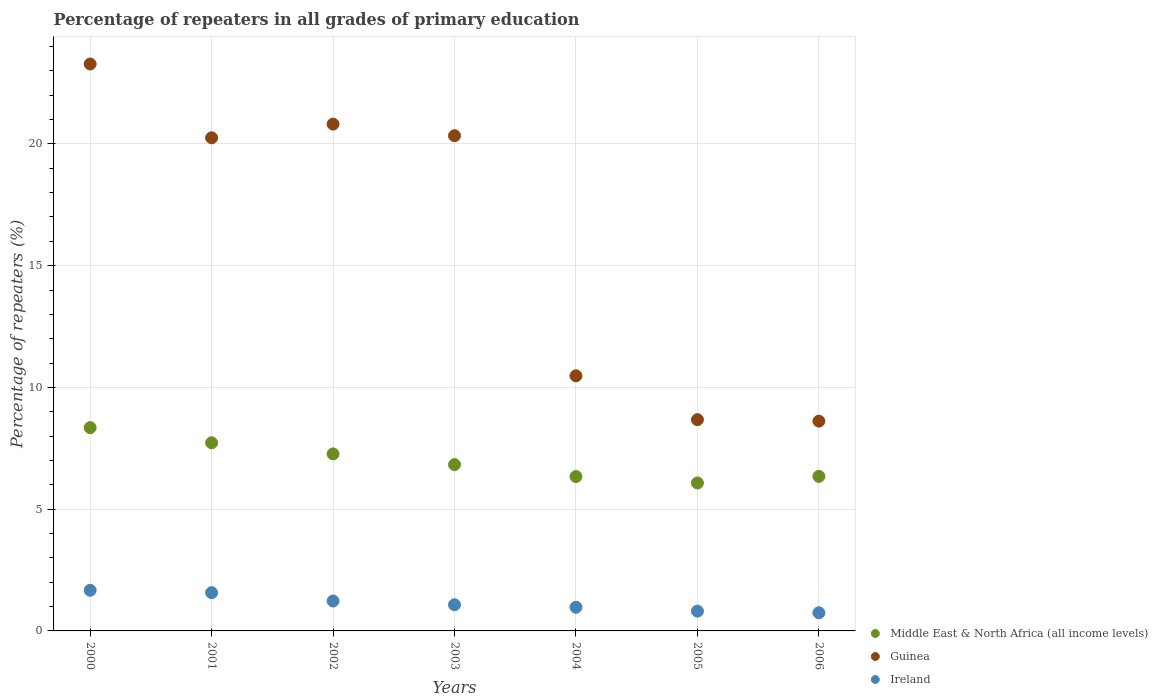How many different coloured dotlines are there?
Offer a very short reply. 3. Is the number of dotlines equal to the number of legend labels?
Make the answer very short. Yes. What is the percentage of repeaters in Middle East & North Africa (all income levels) in 2002?
Your answer should be compact. 7.27. Across all years, what is the maximum percentage of repeaters in Guinea?
Your answer should be compact. 23.28. Across all years, what is the minimum percentage of repeaters in Guinea?
Your answer should be very brief. 8.62. What is the total percentage of repeaters in Ireland in the graph?
Provide a short and direct response. 8.07. What is the difference between the percentage of repeaters in Ireland in 2000 and that in 2004?
Keep it short and to the point. 0.7. What is the difference between the percentage of repeaters in Ireland in 2003 and the percentage of repeaters in Middle East & North Africa (all income levels) in 2000?
Your answer should be very brief. -7.27. What is the average percentage of repeaters in Ireland per year?
Give a very brief answer. 1.15. In the year 2000, what is the difference between the percentage of repeaters in Middle East & North Africa (all income levels) and percentage of repeaters in Ireland?
Offer a very short reply. 6.68. In how many years, is the percentage of repeaters in Middle East & North Africa (all income levels) greater than 9 %?
Your response must be concise. 0. What is the ratio of the percentage of repeaters in Ireland in 2002 to that in 2003?
Give a very brief answer. 1.14. Is the difference between the percentage of repeaters in Middle East & North Africa (all income levels) in 2001 and 2004 greater than the difference between the percentage of repeaters in Ireland in 2001 and 2004?
Your answer should be compact. Yes. What is the difference between the highest and the second highest percentage of repeaters in Guinea?
Offer a very short reply. 2.47. What is the difference between the highest and the lowest percentage of repeaters in Guinea?
Keep it short and to the point. 14.67. Is it the case that in every year, the sum of the percentage of repeaters in Ireland and percentage of repeaters in Middle East & North Africa (all income levels)  is greater than the percentage of repeaters in Guinea?
Give a very brief answer. No. Is the percentage of repeaters in Ireland strictly less than the percentage of repeaters in Middle East & North Africa (all income levels) over the years?
Provide a short and direct response. Yes. What is the difference between two consecutive major ticks on the Y-axis?
Provide a succinct answer. 5. Does the graph contain grids?
Give a very brief answer. Yes. Where does the legend appear in the graph?
Your response must be concise. Bottom right. What is the title of the graph?
Offer a terse response. Percentage of repeaters in all grades of primary education. What is the label or title of the X-axis?
Make the answer very short. Years. What is the label or title of the Y-axis?
Provide a succinct answer. Percentage of repeaters (%). What is the Percentage of repeaters (%) in Middle East & North Africa (all income levels) in 2000?
Make the answer very short. 8.35. What is the Percentage of repeaters (%) of Guinea in 2000?
Provide a short and direct response. 23.28. What is the Percentage of repeaters (%) in Ireland in 2000?
Make the answer very short. 1.67. What is the Percentage of repeaters (%) of Middle East & North Africa (all income levels) in 2001?
Offer a very short reply. 7.73. What is the Percentage of repeaters (%) of Guinea in 2001?
Your answer should be compact. 20.25. What is the Percentage of repeaters (%) in Ireland in 2001?
Your answer should be very brief. 1.57. What is the Percentage of repeaters (%) in Middle East & North Africa (all income levels) in 2002?
Your response must be concise. 7.27. What is the Percentage of repeaters (%) of Guinea in 2002?
Make the answer very short. 20.81. What is the Percentage of repeaters (%) in Ireland in 2002?
Make the answer very short. 1.23. What is the Percentage of repeaters (%) in Middle East & North Africa (all income levels) in 2003?
Ensure brevity in your answer.  6.83. What is the Percentage of repeaters (%) in Guinea in 2003?
Offer a very short reply. 20.34. What is the Percentage of repeaters (%) in Ireland in 2003?
Provide a short and direct response. 1.07. What is the Percentage of repeaters (%) in Middle East & North Africa (all income levels) in 2004?
Offer a terse response. 6.34. What is the Percentage of repeaters (%) in Guinea in 2004?
Your answer should be very brief. 10.48. What is the Percentage of repeaters (%) in Ireland in 2004?
Make the answer very short. 0.97. What is the Percentage of repeaters (%) in Middle East & North Africa (all income levels) in 2005?
Your answer should be very brief. 6.08. What is the Percentage of repeaters (%) of Guinea in 2005?
Provide a short and direct response. 8.68. What is the Percentage of repeaters (%) in Ireland in 2005?
Your response must be concise. 0.81. What is the Percentage of repeaters (%) in Middle East & North Africa (all income levels) in 2006?
Provide a short and direct response. 6.35. What is the Percentage of repeaters (%) of Guinea in 2006?
Give a very brief answer. 8.62. What is the Percentage of repeaters (%) of Ireland in 2006?
Your answer should be very brief. 0.75. Across all years, what is the maximum Percentage of repeaters (%) of Middle East & North Africa (all income levels)?
Your answer should be compact. 8.35. Across all years, what is the maximum Percentage of repeaters (%) of Guinea?
Offer a terse response. 23.28. Across all years, what is the maximum Percentage of repeaters (%) in Ireland?
Provide a succinct answer. 1.67. Across all years, what is the minimum Percentage of repeaters (%) in Middle East & North Africa (all income levels)?
Your response must be concise. 6.08. Across all years, what is the minimum Percentage of repeaters (%) in Guinea?
Provide a succinct answer. 8.62. Across all years, what is the minimum Percentage of repeaters (%) in Ireland?
Make the answer very short. 0.75. What is the total Percentage of repeaters (%) of Middle East & North Africa (all income levels) in the graph?
Provide a short and direct response. 48.94. What is the total Percentage of repeaters (%) of Guinea in the graph?
Offer a very short reply. 112.45. What is the total Percentage of repeaters (%) of Ireland in the graph?
Make the answer very short. 8.07. What is the difference between the Percentage of repeaters (%) in Middle East & North Africa (all income levels) in 2000 and that in 2001?
Your response must be concise. 0.62. What is the difference between the Percentage of repeaters (%) in Guinea in 2000 and that in 2001?
Provide a short and direct response. 3.03. What is the difference between the Percentage of repeaters (%) in Ireland in 2000 and that in 2001?
Ensure brevity in your answer.  0.1. What is the difference between the Percentage of repeaters (%) of Middle East & North Africa (all income levels) in 2000 and that in 2002?
Ensure brevity in your answer.  1.08. What is the difference between the Percentage of repeaters (%) in Guinea in 2000 and that in 2002?
Offer a very short reply. 2.47. What is the difference between the Percentage of repeaters (%) in Ireland in 2000 and that in 2002?
Your answer should be very brief. 0.44. What is the difference between the Percentage of repeaters (%) in Middle East & North Africa (all income levels) in 2000 and that in 2003?
Offer a terse response. 1.52. What is the difference between the Percentage of repeaters (%) of Guinea in 2000 and that in 2003?
Offer a terse response. 2.94. What is the difference between the Percentage of repeaters (%) in Ireland in 2000 and that in 2003?
Your answer should be very brief. 0.59. What is the difference between the Percentage of repeaters (%) in Middle East & North Africa (all income levels) in 2000 and that in 2004?
Offer a very short reply. 2.01. What is the difference between the Percentage of repeaters (%) of Guinea in 2000 and that in 2004?
Provide a short and direct response. 12.8. What is the difference between the Percentage of repeaters (%) of Ireland in 2000 and that in 2004?
Ensure brevity in your answer.  0.7. What is the difference between the Percentage of repeaters (%) of Middle East & North Africa (all income levels) in 2000 and that in 2005?
Provide a short and direct response. 2.27. What is the difference between the Percentage of repeaters (%) in Guinea in 2000 and that in 2005?
Your answer should be very brief. 14.61. What is the difference between the Percentage of repeaters (%) in Ireland in 2000 and that in 2005?
Offer a terse response. 0.86. What is the difference between the Percentage of repeaters (%) of Middle East & North Africa (all income levels) in 2000 and that in 2006?
Keep it short and to the point. 2. What is the difference between the Percentage of repeaters (%) in Guinea in 2000 and that in 2006?
Offer a very short reply. 14.67. What is the difference between the Percentage of repeaters (%) of Ireland in 2000 and that in 2006?
Keep it short and to the point. 0.92. What is the difference between the Percentage of repeaters (%) in Middle East & North Africa (all income levels) in 2001 and that in 2002?
Ensure brevity in your answer.  0.46. What is the difference between the Percentage of repeaters (%) of Guinea in 2001 and that in 2002?
Your answer should be very brief. -0.56. What is the difference between the Percentage of repeaters (%) in Ireland in 2001 and that in 2002?
Give a very brief answer. 0.34. What is the difference between the Percentage of repeaters (%) of Middle East & North Africa (all income levels) in 2001 and that in 2003?
Your answer should be compact. 0.9. What is the difference between the Percentage of repeaters (%) of Guinea in 2001 and that in 2003?
Give a very brief answer. -0.09. What is the difference between the Percentage of repeaters (%) in Ireland in 2001 and that in 2003?
Offer a terse response. 0.5. What is the difference between the Percentage of repeaters (%) in Middle East & North Africa (all income levels) in 2001 and that in 2004?
Offer a terse response. 1.39. What is the difference between the Percentage of repeaters (%) of Guinea in 2001 and that in 2004?
Your response must be concise. 9.77. What is the difference between the Percentage of repeaters (%) of Ireland in 2001 and that in 2004?
Offer a terse response. 0.6. What is the difference between the Percentage of repeaters (%) of Middle East & North Africa (all income levels) in 2001 and that in 2005?
Your response must be concise. 1.65. What is the difference between the Percentage of repeaters (%) in Guinea in 2001 and that in 2005?
Your answer should be very brief. 11.58. What is the difference between the Percentage of repeaters (%) in Ireland in 2001 and that in 2005?
Offer a very short reply. 0.76. What is the difference between the Percentage of repeaters (%) of Middle East & North Africa (all income levels) in 2001 and that in 2006?
Your answer should be very brief. 1.38. What is the difference between the Percentage of repeaters (%) of Guinea in 2001 and that in 2006?
Ensure brevity in your answer.  11.64. What is the difference between the Percentage of repeaters (%) in Ireland in 2001 and that in 2006?
Offer a very short reply. 0.82. What is the difference between the Percentage of repeaters (%) of Middle East & North Africa (all income levels) in 2002 and that in 2003?
Give a very brief answer. 0.44. What is the difference between the Percentage of repeaters (%) in Guinea in 2002 and that in 2003?
Provide a short and direct response. 0.48. What is the difference between the Percentage of repeaters (%) in Ireland in 2002 and that in 2003?
Make the answer very short. 0.15. What is the difference between the Percentage of repeaters (%) in Middle East & North Africa (all income levels) in 2002 and that in 2004?
Your answer should be compact. 0.93. What is the difference between the Percentage of repeaters (%) of Guinea in 2002 and that in 2004?
Provide a succinct answer. 10.34. What is the difference between the Percentage of repeaters (%) of Ireland in 2002 and that in 2004?
Keep it short and to the point. 0.26. What is the difference between the Percentage of repeaters (%) in Middle East & North Africa (all income levels) in 2002 and that in 2005?
Keep it short and to the point. 1.19. What is the difference between the Percentage of repeaters (%) of Guinea in 2002 and that in 2005?
Provide a succinct answer. 12.14. What is the difference between the Percentage of repeaters (%) in Ireland in 2002 and that in 2005?
Your response must be concise. 0.42. What is the difference between the Percentage of repeaters (%) of Middle East & North Africa (all income levels) in 2002 and that in 2006?
Your response must be concise. 0.92. What is the difference between the Percentage of repeaters (%) of Guinea in 2002 and that in 2006?
Give a very brief answer. 12.2. What is the difference between the Percentage of repeaters (%) of Ireland in 2002 and that in 2006?
Make the answer very short. 0.48. What is the difference between the Percentage of repeaters (%) in Middle East & North Africa (all income levels) in 2003 and that in 2004?
Ensure brevity in your answer.  0.49. What is the difference between the Percentage of repeaters (%) in Guinea in 2003 and that in 2004?
Provide a succinct answer. 9.86. What is the difference between the Percentage of repeaters (%) of Ireland in 2003 and that in 2004?
Keep it short and to the point. 0.1. What is the difference between the Percentage of repeaters (%) of Middle East & North Africa (all income levels) in 2003 and that in 2005?
Make the answer very short. 0.75. What is the difference between the Percentage of repeaters (%) in Guinea in 2003 and that in 2005?
Give a very brief answer. 11.66. What is the difference between the Percentage of repeaters (%) in Ireland in 2003 and that in 2005?
Offer a terse response. 0.26. What is the difference between the Percentage of repeaters (%) of Middle East & North Africa (all income levels) in 2003 and that in 2006?
Ensure brevity in your answer.  0.48. What is the difference between the Percentage of repeaters (%) of Guinea in 2003 and that in 2006?
Keep it short and to the point. 11.72. What is the difference between the Percentage of repeaters (%) in Ireland in 2003 and that in 2006?
Offer a terse response. 0.33. What is the difference between the Percentage of repeaters (%) in Middle East & North Africa (all income levels) in 2004 and that in 2005?
Ensure brevity in your answer.  0.26. What is the difference between the Percentage of repeaters (%) in Guinea in 2004 and that in 2005?
Keep it short and to the point. 1.8. What is the difference between the Percentage of repeaters (%) of Ireland in 2004 and that in 2005?
Offer a terse response. 0.16. What is the difference between the Percentage of repeaters (%) in Middle East & North Africa (all income levels) in 2004 and that in 2006?
Your answer should be very brief. -0. What is the difference between the Percentage of repeaters (%) of Guinea in 2004 and that in 2006?
Keep it short and to the point. 1.86. What is the difference between the Percentage of repeaters (%) in Ireland in 2004 and that in 2006?
Provide a succinct answer. 0.23. What is the difference between the Percentage of repeaters (%) in Middle East & North Africa (all income levels) in 2005 and that in 2006?
Make the answer very short. -0.27. What is the difference between the Percentage of repeaters (%) of Guinea in 2005 and that in 2006?
Provide a short and direct response. 0.06. What is the difference between the Percentage of repeaters (%) in Ireland in 2005 and that in 2006?
Offer a very short reply. 0.07. What is the difference between the Percentage of repeaters (%) of Middle East & North Africa (all income levels) in 2000 and the Percentage of repeaters (%) of Guinea in 2001?
Offer a very short reply. -11.9. What is the difference between the Percentage of repeaters (%) in Middle East & North Africa (all income levels) in 2000 and the Percentage of repeaters (%) in Ireland in 2001?
Your answer should be compact. 6.78. What is the difference between the Percentage of repeaters (%) of Guinea in 2000 and the Percentage of repeaters (%) of Ireland in 2001?
Ensure brevity in your answer.  21.71. What is the difference between the Percentage of repeaters (%) in Middle East & North Africa (all income levels) in 2000 and the Percentage of repeaters (%) in Guinea in 2002?
Your answer should be compact. -12.47. What is the difference between the Percentage of repeaters (%) of Middle East & North Africa (all income levels) in 2000 and the Percentage of repeaters (%) of Ireland in 2002?
Provide a short and direct response. 7.12. What is the difference between the Percentage of repeaters (%) in Guinea in 2000 and the Percentage of repeaters (%) in Ireland in 2002?
Give a very brief answer. 22.05. What is the difference between the Percentage of repeaters (%) in Middle East & North Africa (all income levels) in 2000 and the Percentage of repeaters (%) in Guinea in 2003?
Give a very brief answer. -11.99. What is the difference between the Percentage of repeaters (%) in Middle East & North Africa (all income levels) in 2000 and the Percentage of repeaters (%) in Ireland in 2003?
Keep it short and to the point. 7.27. What is the difference between the Percentage of repeaters (%) in Guinea in 2000 and the Percentage of repeaters (%) in Ireland in 2003?
Provide a short and direct response. 22.21. What is the difference between the Percentage of repeaters (%) of Middle East & North Africa (all income levels) in 2000 and the Percentage of repeaters (%) of Guinea in 2004?
Your answer should be very brief. -2.13. What is the difference between the Percentage of repeaters (%) of Middle East & North Africa (all income levels) in 2000 and the Percentage of repeaters (%) of Ireland in 2004?
Your response must be concise. 7.38. What is the difference between the Percentage of repeaters (%) of Guinea in 2000 and the Percentage of repeaters (%) of Ireland in 2004?
Ensure brevity in your answer.  22.31. What is the difference between the Percentage of repeaters (%) of Middle East & North Africa (all income levels) in 2000 and the Percentage of repeaters (%) of Guinea in 2005?
Make the answer very short. -0.33. What is the difference between the Percentage of repeaters (%) in Middle East & North Africa (all income levels) in 2000 and the Percentage of repeaters (%) in Ireland in 2005?
Offer a very short reply. 7.54. What is the difference between the Percentage of repeaters (%) in Guinea in 2000 and the Percentage of repeaters (%) in Ireland in 2005?
Offer a terse response. 22.47. What is the difference between the Percentage of repeaters (%) in Middle East & North Africa (all income levels) in 2000 and the Percentage of repeaters (%) in Guinea in 2006?
Keep it short and to the point. -0.27. What is the difference between the Percentage of repeaters (%) in Middle East & North Africa (all income levels) in 2000 and the Percentage of repeaters (%) in Ireland in 2006?
Your response must be concise. 7.6. What is the difference between the Percentage of repeaters (%) in Guinea in 2000 and the Percentage of repeaters (%) in Ireland in 2006?
Keep it short and to the point. 22.54. What is the difference between the Percentage of repeaters (%) in Middle East & North Africa (all income levels) in 2001 and the Percentage of repeaters (%) in Guinea in 2002?
Offer a terse response. -13.09. What is the difference between the Percentage of repeaters (%) of Middle East & North Africa (all income levels) in 2001 and the Percentage of repeaters (%) of Ireland in 2002?
Make the answer very short. 6.5. What is the difference between the Percentage of repeaters (%) of Guinea in 2001 and the Percentage of repeaters (%) of Ireland in 2002?
Ensure brevity in your answer.  19.02. What is the difference between the Percentage of repeaters (%) of Middle East & North Africa (all income levels) in 2001 and the Percentage of repeaters (%) of Guinea in 2003?
Offer a very short reply. -12.61. What is the difference between the Percentage of repeaters (%) in Middle East & North Africa (all income levels) in 2001 and the Percentage of repeaters (%) in Ireland in 2003?
Keep it short and to the point. 6.65. What is the difference between the Percentage of repeaters (%) in Guinea in 2001 and the Percentage of repeaters (%) in Ireland in 2003?
Offer a very short reply. 19.18. What is the difference between the Percentage of repeaters (%) in Middle East & North Africa (all income levels) in 2001 and the Percentage of repeaters (%) in Guinea in 2004?
Your response must be concise. -2.75. What is the difference between the Percentage of repeaters (%) of Middle East & North Africa (all income levels) in 2001 and the Percentage of repeaters (%) of Ireland in 2004?
Your answer should be very brief. 6.76. What is the difference between the Percentage of repeaters (%) of Guinea in 2001 and the Percentage of repeaters (%) of Ireland in 2004?
Keep it short and to the point. 19.28. What is the difference between the Percentage of repeaters (%) in Middle East & North Africa (all income levels) in 2001 and the Percentage of repeaters (%) in Guinea in 2005?
Ensure brevity in your answer.  -0.95. What is the difference between the Percentage of repeaters (%) in Middle East & North Africa (all income levels) in 2001 and the Percentage of repeaters (%) in Ireland in 2005?
Offer a terse response. 6.91. What is the difference between the Percentage of repeaters (%) in Guinea in 2001 and the Percentage of repeaters (%) in Ireland in 2005?
Keep it short and to the point. 19.44. What is the difference between the Percentage of repeaters (%) in Middle East & North Africa (all income levels) in 2001 and the Percentage of repeaters (%) in Guinea in 2006?
Your response must be concise. -0.89. What is the difference between the Percentage of repeaters (%) in Middle East & North Africa (all income levels) in 2001 and the Percentage of repeaters (%) in Ireland in 2006?
Ensure brevity in your answer.  6.98. What is the difference between the Percentage of repeaters (%) in Guinea in 2001 and the Percentage of repeaters (%) in Ireland in 2006?
Keep it short and to the point. 19.51. What is the difference between the Percentage of repeaters (%) of Middle East & North Africa (all income levels) in 2002 and the Percentage of repeaters (%) of Guinea in 2003?
Give a very brief answer. -13.07. What is the difference between the Percentage of repeaters (%) of Middle East & North Africa (all income levels) in 2002 and the Percentage of repeaters (%) of Ireland in 2003?
Provide a short and direct response. 6.2. What is the difference between the Percentage of repeaters (%) of Guinea in 2002 and the Percentage of repeaters (%) of Ireland in 2003?
Offer a terse response. 19.74. What is the difference between the Percentage of repeaters (%) of Middle East & North Africa (all income levels) in 2002 and the Percentage of repeaters (%) of Guinea in 2004?
Provide a succinct answer. -3.21. What is the difference between the Percentage of repeaters (%) in Middle East & North Africa (all income levels) in 2002 and the Percentage of repeaters (%) in Ireland in 2004?
Ensure brevity in your answer.  6.3. What is the difference between the Percentage of repeaters (%) in Guinea in 2002 and the Percentage of repeaters (%) in Ireland in 2004?
Your answer should be compact. 19.84. What is the difference between the Percentage of repeaters (%) in Middle East & North Africa (all income levels) in 2002 and the Percentage of repeaters (%) in Guinea in 2005?
Your answer should be very brief. -1.41. What is the difference between the Percentage of repeaters (%) of Middle East & North Africa (all income levels) in 2002 and the Percentage of repeaters (%) of Ireland in 2005?
Your answer should be very brief. 6.46. What is the difference between the Percentage of repeaters (%) of Guinea in 2002 and the Percentage of repeaters (%) of Ireland in 2005?
Offer a terse response. 20. What is the difference between the Percentage of repeaters (%) of Middle East & North Africa (all income levels) in 2002 and the Percentage of repeaters (%) of Guinea in 2006?
Make the answer very short. -1.34. What is the difference between the Percentage of repeaters (%) in Middle East & North Africa (all income levels) in 2002 and the Percentage of repeaters (%) in Ireland in 2006?
Keep it short and to the point. 6.52. What is the difference between the Percentage of repeaters (%) in Guinea in 2002 and the Percentage of repeaters (%) in Ireland in 2006?
Keep it short and to the point. 20.07. What is the difference between the Percentage of repeaters (%) of Middle East & North Africa (all income levels) in 2003 and the Percentage of repeaters (%) of Guinea in 2004?
Keep it short and to the point. -3.65. What is the difference between the Percentage of repeaters (%) in Middle East & North Africa (all income levels) in 2003 and the Percentage of repeaters (%) in Ireland in 2004?
Your answer should be very brief. 5.86. What is the difference between the Percentage of repeaters (%) in Guinea in 2003 and the Percentage of repeaters (%) in Ireland in 2004?
Ensure brevity in your answer.  19.37. What is the difference between the Percentage of repeaters (%) in Middle East & North Africa (all income levels) in 2003 and the Percentage of repeaters (%) in Guinea in 2005?
Ensure brevity in your answer.  -1.85. What is the difference between the Percentage of repeaters (%) of Middle East & North Africa (all income levels) in 2003 and the Percentage of repeaters (%) of Ireland in 2005?
Your answer should be very brief. 6.02. What is the difference between the Percentage of repeaters (%) of Guinea in 2003 and the Percentage of repeaters (%) of Ireland in 2005?
Make the answer very short. 19.52. What is the difference between the Percentage of repeaters (%) in Middle East & North Africa (all income levels) in 2003 and the Percentage of repeaters (%) in Guinea in 2006?
Make the answer very short. -1.79. What is the difference between the Percentage of repeaters (%) of Middle East & North Africa (all income levels) in 2003 and the Percentage of repeaters (%) of Ireland in 2006?
Provide a short and direct response. 6.08. What is the difference between the Percentage of repeaters (%) of Guinea in 2003 and the Percentage of repeaters (%) of Ireland in 2006?
Give a very brief answer. 19.59. What is the difference between the Percentage of repeaters (%) of Middle East & North Africa (all income levels) in 2004 and the Percentage of repeaters (%) of Guinea in 2005?
Your answer should be compact. -2.33. What is the difference between the Percentage of repeaters (%) of Middle East & North Africa (all income levels) in 2004 and the Percentage of repeaters (%) of Ireland in 2005?
Offer a terse response. 5.53. What is the difference between the Percentage of repeaters (%) of Guinea in 2004 and the Percentage of repeaters (%) of Ireland in 2005?
Give a very brief answer. 9.66. What is the difference between the Percentage of repeaters (%) of Middle East & North Africa (all income levels) in 2004 and the Percentage of repeaters (%) of Guinea in 2006?
Make the answer very short. -2.27. What is the difference between the Percentage of repeaters (%) in Middle East & North Africa (all income levels) in 2004 and the Percentage of repeaters (%) in Ireland in 2006?
Your response must be concise. 5.59. What is the difference between the Percentage of repeaters (%) in Guinea in 2004 and the Percentage of repeaters (%) in Ireland in 2006?
Your answer should be very brief. 9.73. What is the difference between the Percentage of repeaters (%) of Middle East & North Africa (all income levels) in 2005 and the Percentage of repeaters (%) of Guinea in 2006?
Provide a succinct answer. -2.54. What is the difference between the Percentage of repeaters (%) in Middle East & North Africa (all income levels) in 2005 and the Percentage of repeaters (%) in Ireland in 2006?
Provide a succinct answer. 5.33. What is the difference between the Percentage of repeaters (%) of Guinea in 2005 and the Percentage of repeaters (%) of Ireland in 2006?
Ensure brevity in your answer.  7.93. What is the average Percentage of repeaters (%) of Middle East & North Africa (all income levels) per year?
Provide a succinct answer. 6.99. What is the average Percentage of repeaters (%) in Guinea per year?
Your answer should be very brief. 16.07. What is the average Percentage of repeaters (%) in Ireland per year?
Keep it short and to the point. 1.15. In the year 2000, what is the difference between the Percentage of repeaters (%) of Middle East & North Africa (all income levels) and Percentage of repeaters (%) of Guinea?
Provide a short and direct response. -14.93. In the year 2000, what is the difference between the Percentage of repeaters (%) of Middle East & North Africa (all income levels) and Percentage of repeaters (%) of Ireland?
Your answer should be compact. 6.68. In the year 2000, what is the difference between the Percentage of repeaters (%) in Guinea and Percentage of repeaters (%) in Ireland?
Ensure brevity in your answer.  21.61. In the year 2001, what is the difference between the Percentage of repeaters (%) in Middle East & North Africa (all income levels) and Percentage of repeaters (%) in Guinea?
Keep it short and to the point. -12.52. In the year 2001, what is the difference between the Percentage of repeaters (%) in Middle East & North Africa (all income levels) and Percentage of repeaters (%) in Ireland?
Provide a short and direct response. 6.16. In the year 2001, what is the difference between the Percentage of repeaters (%) in Guinea and Percentage of repeaters (%) in Ireland?
Your response must be concise. 18.68. In the year 2002, what is the difference between the Percentage of repeaters (%) in Middle East & North Africa (all income levels) and Percentage of repeaters (%) in Guinea?
Offer a very short reply. -13.54. In the year 2002, what is the difference between the Percentage of repeaters (%) of Middle East & North Africa (all income levels) and Percentage of repeaters (%) of Ireland?
Provide a succinct answer. 6.04. In the year 2002, what is the difference between the Percentage of repeaters (%) in Guinea and Percentage of repeaters (%) in Ireland?
Provide a short and direct response. 19.59. In the year 2003, what is the difference between the Percentage of repeaters (%) in Middle East & North Africa (all income levels) and Percentage of repeaters (%) in Guinea?
Keep it short and to the point. -13.51. In the year 2003, what is the difference between the Percentage of repeaters (%) of Middle East & North Africa (all income levels) and Percentage of repeaters (%) of Ireland?
Keep it short and to the point. 5.75. In the year 2003, what is the difference between the Percentage of repeaters (%) of Guinea and Percentage of repeaters (%) of Ireland?
Keep it short and to the point. 19.26. In the year 2004, what is the difference between the Percentage of repeaters (%) in Middle East & North Africa (all income levels) and Percentage of repeaters (%) in Guinea?
Your response must be concise. -4.14. In the year 2004, what is the difference between the Percentage of repeaters (%) of Middle East & North Africa (all income levels) and Percentage of repeaters (%) of Ireland?
Ensure brevity in your answer.  5.37. In the year 2004, what is the difference between the Percentage of repeaters (%) in Guinea and Percentage of repeaters (%) in Ireland?
Keep it short and to the point. 9.51. In the year 2005, what is the difference between the Percentage of repeaters (%) of Middle East & North Africa (all income levels) and Percentage of repeaters (%) of Guinea?
Your response must be concise. -2.6. In the year 2005, what is the difference between the Percentage of repeaters (%) of Middle East & North Africa (all income levels) and Percentage of repeaters (%) of Ireland?
Your response must be concise. 5.26. In the year 2005, what is the difference between the Percentage of repeaters (%) in Guinea and Percentage of repeaters (%) in Ireland?
Keep it short and to the point. 7.86. In the year 2006, what is the difference between the Percentage of repeaters (%) of Middle East & North Africa (all income levels) and Percentage of repeaters (%) of Guinea?
Keep it short and to the point. -2.27. In the year 2006, what is the difference between the Percentage of repeaters (%) in Middle East & North Africa (all income levels) and Percentage of repeaters (%) in Ireland?
Provide a succinct answer. 5.6. In the year 2006, what is the difference between the Percentage of repeaters (%) of Guinea and Percentage of repeaters (%) of Ireland?
Ensure brevity in your answer.  7.87. What is the ratio of the Percentage of repeaters (%) in Middle East & North Africa (all income levels) in 2000 to that in 2001?
Offer a very short reply. 1.08. What is the ratio of the Percentage of repeaters (%) in Guinea in 2000 to that in 2001?
Offer a very short reply. 1.15. What is the ratio of the Percentage of repeaters (%) of Ireland in 2000 to that in 2001?
Keep it short and to the point. 1.06. What is the ratio of the Percentage of repeaters (%) in Middle East & North Africa (all income levels) in 2000 to that in 2002?
Provide a short and direct response. 1.15. What is the ratio of the Percentage of repeaters (%) in Guinea in 2000 to that in 2002?
Offer a very short reply. 1.12. What is the ratio of the Percentage of repeaters (%) in Ireland in 2000 to that in 2002?
Make the answer very short. 1.36. What is the ratio of the Percentage of repeaters (%) of Middle East & North Africa (all income levels) in 2000 to that in 2003?
Provide a short and direct response. 1.22. What is the ratio of the Percentage of repeaters (%) in Guinea in 2000 to that in 2003?
Keep it short and to the point. 1.14. What is the ratio of the Percentage of repeaters (%) in Ireland in 2000 to that in 2003?
Keep it short and to the point. 1.55. What is the ratio of the Percentage of repeaters (%) of Middle East & North Africa (all income levels) in 2000 to that in 2004?
Your answer should be very brief. 1.32. What is the ratio of the Percentage of repeaters (%) of Guinea in 2000 to that in 2004?
Keep it short and to the point. 2.22. What is the ratio of the Percentage of repeaters (%) in Ireland in 2000 to that in 2004?
Your answer should be very brief. 1.72. What is the ratio of the Percentage of repeaters (%) of Middle East & North Africa (all income levels) in 2000 to that in 2005?
Provide a succinct answer. 1.37. What is the ratio of the Percentage of repeaters (%) in Guinea in 2000 to that in 2005?
Provide a succinct answer. 2.68. What is the ratio of the Percentage of repeaters (%) of Ireland in 2000 to that in 2005?
Provide a short and direct response. 2.05. What is the ratio of the Percentage of repeaters (%) of Middle East & North Africa (all income levels) in 2000 to that in 2006?
Your answer should be very brief. 1.32. What is the ratio of the Percentage of repeaters (%) of Guinea in 2000 to that in 2006?
Your answer should be very brief. 2.7. What is the ratio of the Percentage of repeaters (%) of Ireland in 2000 to that in 2006?
Your answer should be compact. 2.24. What is the ratio of the Percentage of repeaters (%) in Middle East & North Africa (all income levels) in 2001 to that in 2002?
Make the answer very short. 1.06. What is the ratio of the Percentage of repeaters (%) of Guinea in 2001 to that in 2002?
Make the answer very short. 0.97. What is the ratio of the Percentage of repeaters (%) of Ireland in 2001 to that in 2002?
Offer a very short reply. 1.28. What is the ratio of the Percentage of repeaters (%) of Middle East & North Africa (all income levels) in 2001 to that in 2003?
Offer a terse response. 1.13. What is the ratio of the Percentage of repeaters (%) in Ireland in 2001 to that in 2003?
Ensure brevity in your answer.  1.46. What is the ratio of the Percentage of repeaters (%) of Middle East & North Africa (all income levels) in 2001 to that in 2004?
Your response must be concise. 1.22. What is the ratio of the Percentage of repeaters (%) in Guinea in 2001 to that in 2004?
Offer a terse response. 1.93. What is the ratio of the Percentage of repeaters (%) in Ireland in 2001 to that in 2004?
Make the answer very short. 1.62. What is the ratio of the Percentage of repeaters (%) in Middle East & North Africa (all income levels) in 2001 to that in 2005?
Provide a succinct answer. 1.27. What is the ratio of the Percentage of repeaters (%) in Guinea in 2001 to that in 2005?
Make the answer very short. 2.33. What is the ratio of the Percentage of repeaters (%) of Ireland in 2001 to that in 2005?
Make the answer very short. 1.93. What is the ratio of the Percentage of repeaters (%) of Middle East & North Africa (all income levels) in 2001 to that in 2006?
Provide a short and direct response. 1.22. What is the ratio of the Percentage of repeaters (%) of Guinea in 2001 to that in 2006?
Provide a short and direct response. 2.35. What is the ratio of the Percentage of repeaters (%) in Ireland in 2001 to that in 2006?
Your response must be concise. 2.1. What is the ratio of the Percentage of repeaters (%) in Middle East & North Africa (all income levels) in 2002 to that in 2003?
Ensure brevity in your answer.  1.06. What is the ratio of the Percentage of repeaters (%) of Guinea in 2002 to that in 2003?
Your answer should be compact. 1.02. What is the ratio of the Percentage of repeaters (%) of Ireland in 2002 to that in 2003?
Make the answer very short. 1.14. What is the ratio of the Percentage of repeaters (%) of Middle East & North Africa (all income levels) in 2002 to that in 2004?
Offer a terse response. 1.15. What is the ratio of the Percentage of repeaters (%) of Guinea in 2002 to that in 2004?
Provide a short and direct response. 1.99. What is the ratio of the Percentage of repeaters (%) in Ireland in 2002 to that in 2004?
Ensure brevity in your answer.  1.26. What is the ratio of the Percentage of repeaters (%) in Middle East & North Africa (all income levels) in 2002 to that in 2005?
Provide a short and direct response. 1.2. What is the ratio of the Percentage of repeaters (%) of Guinea in 2002 to that in 2005?
Keep it short and to the point. 2.4. What is the ratio of the Percentage of repeaters (%) of Ireland in 2002 to that in 2005?
Provide a succinct answer. 1.51. What is the ratio of the Percentage of repeaters (%) in Middle East & North Africa (all income levels) in 2002 to that in 2006?
Offer a terse response. 1.15. What is the ratio of the Percentage of repeaters (%) of Guinea in 2002 to that in 2006?
Your answer should be compact. 2.42. What is the ratio of the Percentage of repeaters (%) of Ireland in 2002 to that in 2006?
Give a very brief answer. 1.65. What is the ratio of the Percentage of repeaters (%) in Middle East & North Africa (all income levels) in 2003 to that in 2004?
Offer a very short reply. 1.08. What is the ratio of the Percentage of repeaters (%) of Guinea in 2003 to that in 2004?
Keep it short and to the point. 1.94. What is the ratio of the Percentage of repeaters (%) of Ireland in 2003 to that in 2004?
Provide a short and direct response. 1.11. What is the ratio of the Percentage of repeaters (%) of Middle East & North Africa (all income levels) in 2003 to that in 2005?
Provide a short and direct response. 1.12. What is the ratio of the Percentage of repeaters (%) of Guinea in 2003 to that in 2005?
Offer a terse response. 2.34. What is the ratio of the Percentage of repeaters (%) in Ireland in 2003 to that in 2005?
Your response must be concise. 1.32. What is the ratio of the Percentage of repeaters (%) in Middle East & North Africa (all income levels) in 2003 to that in 2006?
Ensure brevity in your answer.  1.08. What is the ratio of the Percentage of repeaters (%) of Guinea in 2003 to that in 2006?
Give a very brief answer. 2.36. What is the ratio of the Percentage of repeaters (%) of Ireland in 2003 to that in 2006?
Keep it short and to the point. 1.44. What is the ratio of the Percentage of repeaters (%) in Middle East & North Africa (all income levels) in 2004 to that in 2005?
Keep it short and to the point. 1.04. What is the ratio of the Percentage of repeaters (%) in Guinea in 2004 to that in 2005?
Offer a terse response. 1.21. What is the ratio of the Percentage of repeaters (%) in Ireland in 2004 to that in 2005?
Give a very brief answer. 1.2. What is the ratio of the Percentage of repeaters (%) of Guinea in 2004 to that in 2006?
Give a very brief answer. 1.22. What is the ratio of the Percentage of repeaters (%) of Ireland in 2004 to that in 2006?
Offer a very short reply. 1.3. What is the ratio of the Percentage of repeaters (%) in Middle East & North Africa (all income levels) in 2005 to that in 2006?
Make the answer very short. 0.96. What is the ratio of the Percentage of repeaters (%) in Ireland in 2005 to that in 2006?
Provide a succinct answer. 1.09. What is the difference between the highest and the second highest Percentage of repeaters (%) of Middle East & North Africa (all income levels)?
Give a very brief answer. 0.62. What is the difference between the highest and the second highest Percentage of repeaters (%) in Guinea?
Your response must be concise. 2.47. What is the difference between the highest and the second highest Percentage of repeaters (%) of Ireland?
Provide a succinct answer. 0.1. What is the difference between the highest and the lowest Percentage of repeaters (%) of Middle East & North Africa (all income levels)?
Make the answer very short. 2.27. What is the difference between the highest and the lowest Percentage of repeaters (%) in Guinea?
Provide a succinct answer. 14.67. What is the difference between the highest and the lowest Percentage of repeaters (%) in Ireland?
Offer a very short reply. 0.92. 